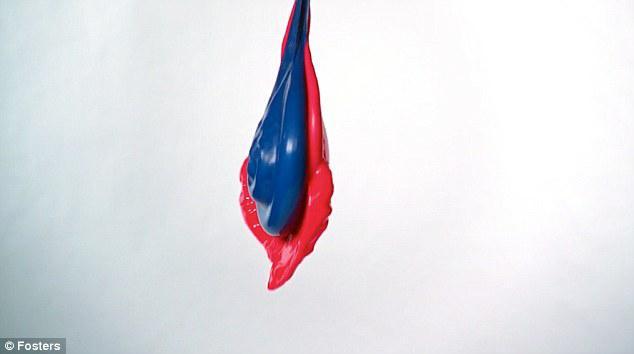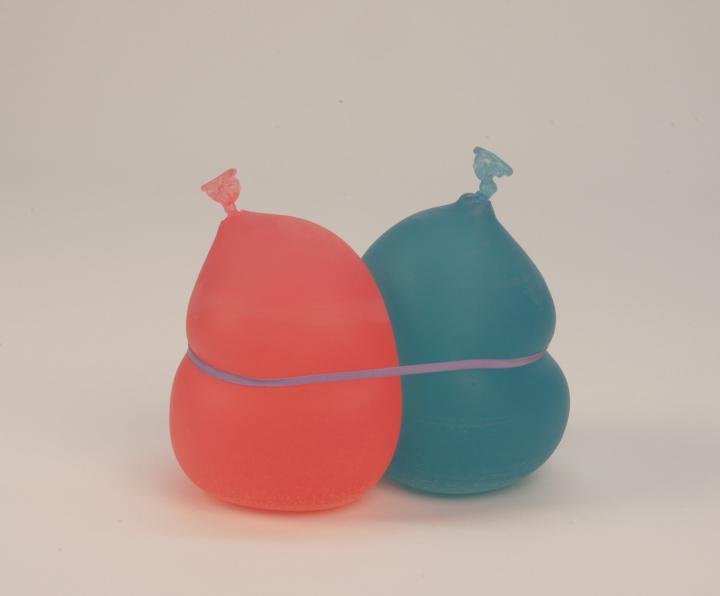The first image is the image on the left, the second image is the image on the right. Analyze the images presented: Is the assertion "Exactly one image shows liquid-like side-by-side drops of blue and red." valid? Answer yes or no. Yes. 